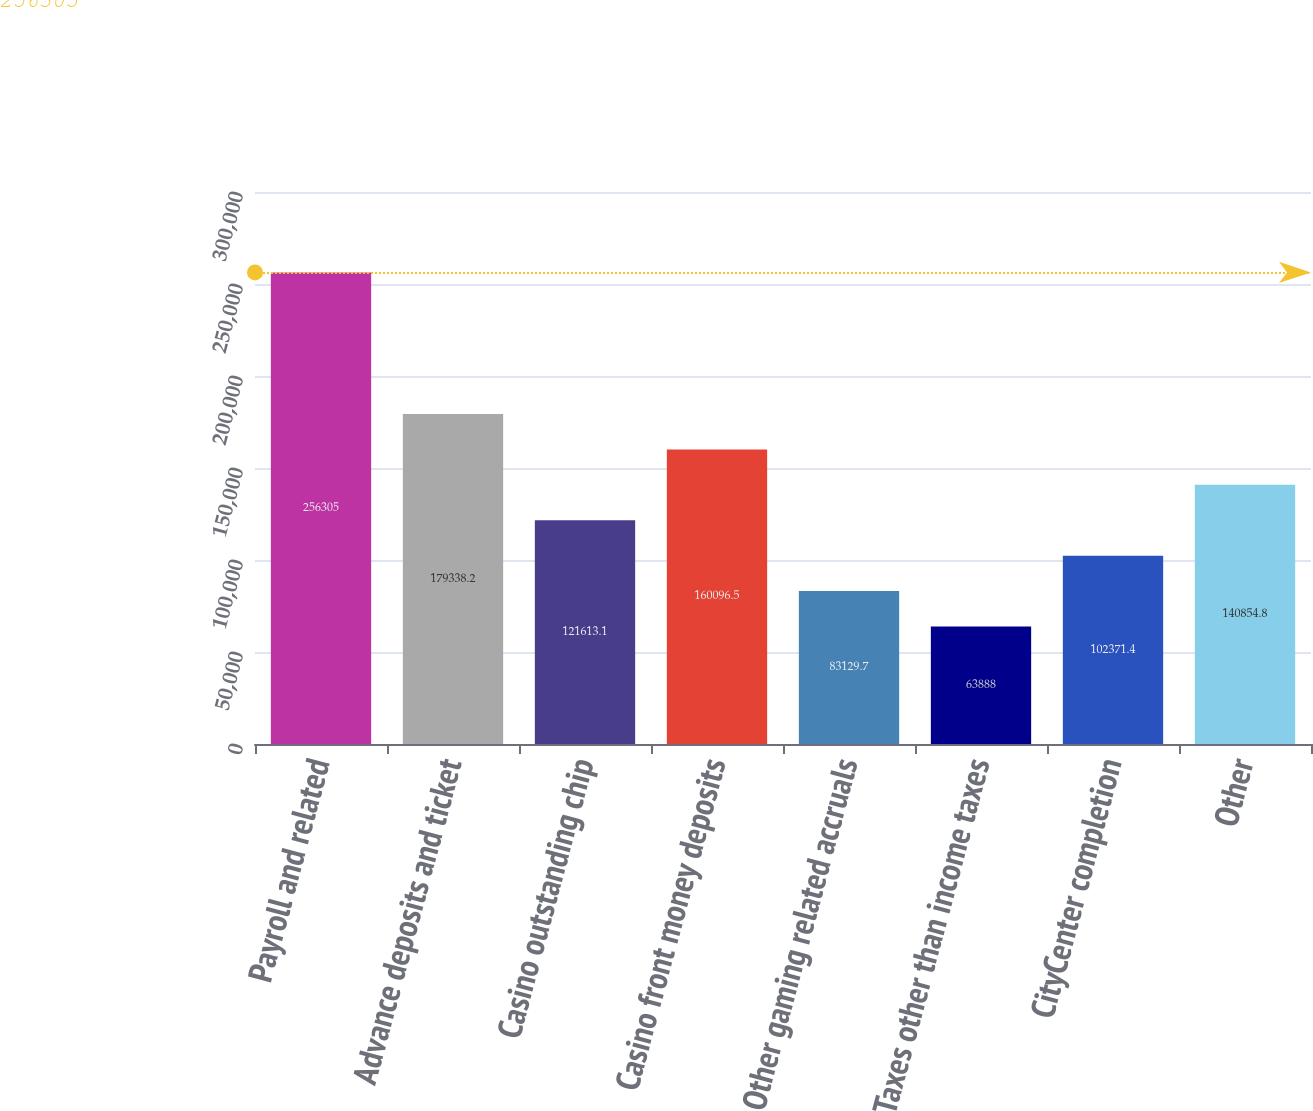Convert chart to OTSL. <chart><loc_0><loc_0><loc_500><loc_500><bar_chart><fcel>Payroll and related<fcel>Advance deposits and ticket<fcel>Casino outstanding chip<fcel>Casino front money deposits<fcel>Other gaming related accruals<fcel>Taxes other than income taxes<fcel>CityCenter completion<fcel>Other<nl><fcel>256305<fcel>179338<fcel>121613<fcel>160096<fcel>83129.7<fcel>63888<fcel>102371<fcel>140855<nl></chart> 